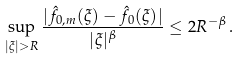Convert formula to latex. <formula><loc_0><loc_0><loc_500><loc_500>\sup _ { | \xi | > R } \frac { | \hat { f } _ { 0 , m } ( \xi ) - \hat { f } _ { 0 } ( \xi ) | } { | \xi | ^ { \beta } } \leq 2 R ^ { - \beta } \, .</formula> 